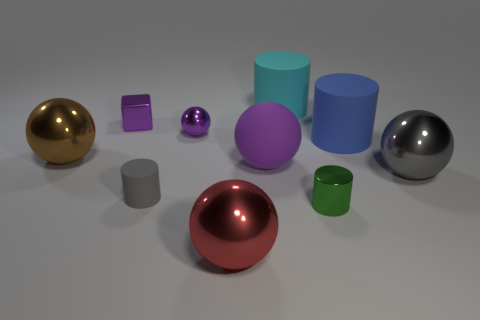Subtract all cyan cubes. Subtract all cyan balls. How many cubes are left? 1 Subtract all purple spheres. How many gray cylinders are left? 1 Add 1 small things. How many big grays exist? 0 Subtract all big purple matte objects. Subtract all small metal spheres. How many objects are left? 8 Add 8 cyan rubber cylinders. How many cyan rubber cylinders are left? 9 Add 6 large cyan matte cylinders. How many large cyan matte cylinders exist? 7 Subtract all gray spheres. How many spheres are left? 4 Subtract all small gray cylinders. How many cylinders are left? 3 Subtract 0 brown blocks. How many objects are left? 10 How many purple spheres must be subtracted to get 1 purple spheres? 1 